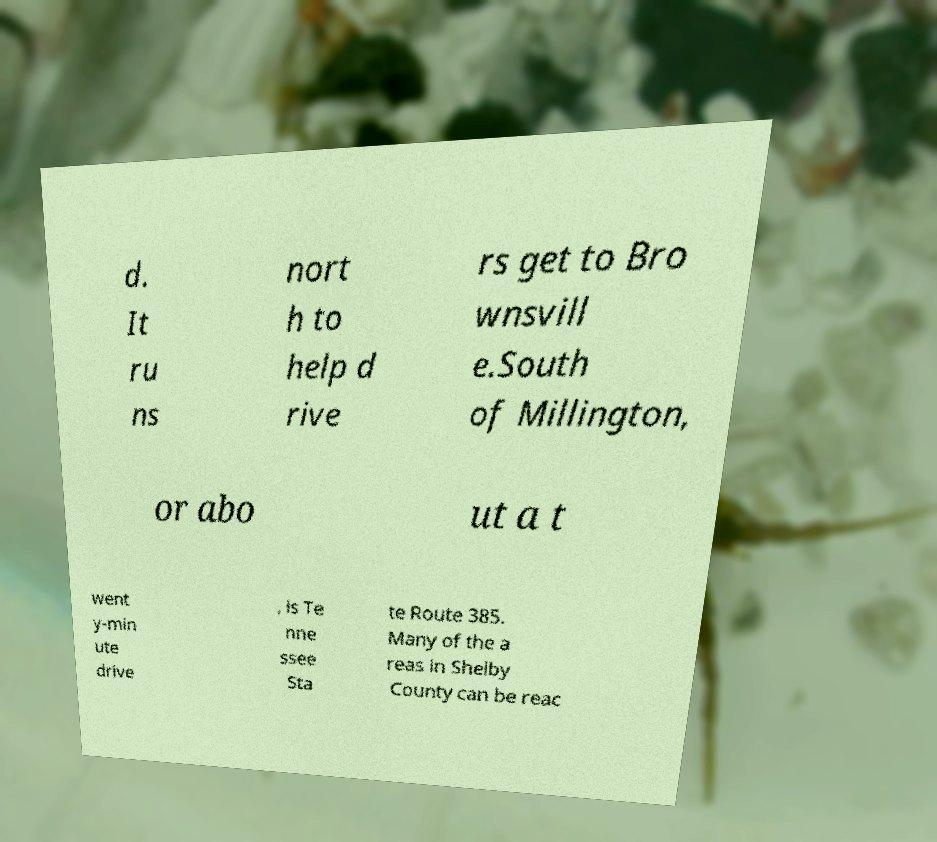There's text embedded in this image that I need extracted. Can you transcribe it verbatim? d. It ru ns nort h to help d rive rs get to Bro wnsvill e.South of Millington, or abo ut a t went y-min ute drive , is Te nne ssee Sta te Route 385. Many of the a reas in Shelby County can be reac 